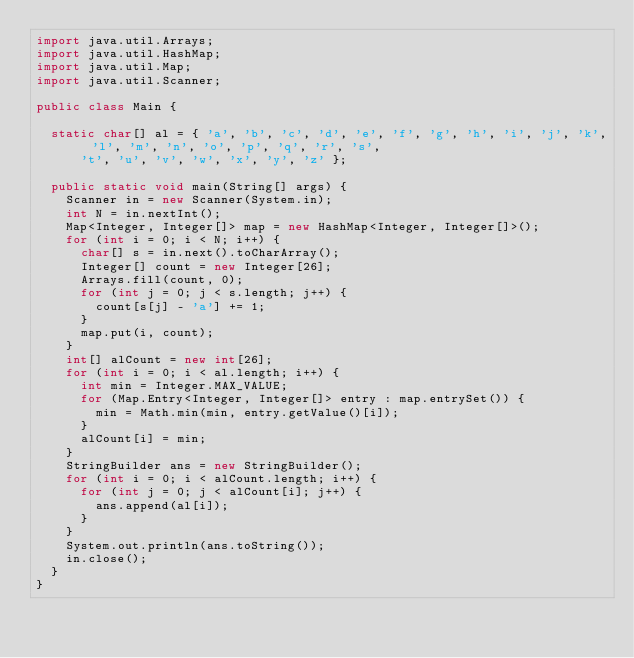<code> <loc_0><loc_0><loc_500><loc_500><_Java_>import java.util.Arrays;
import java.util.HashMap;
import java.util.Map;
import java.util.Scanner;

public class Main {

	static char[] al = { 'a', 'b', 'c', 'd', 'e', 'f', 'g', 'h', 'i', 'j', 'k', 'l', 'm', 'n', 'o', 'p', 'q', 'r', 's',
			't', 'u', 'v', 'w', 'x', 'y', 'z' };

	public static void main(String[] args) {
		Scanner in = new Scanner(System.in);
		int N = in.nextInt();
		Map<Integer, Integer[]> map = new HashMap<Integer, Integer[]>();
		for (int i = 0; i < N; i++) {
			char[] s = in.next().toCharArray();
			Integer[] count = new Integer[26];
			Arrays.fill(count, 0);
			for (int j = 0; j < s.length; j++) {
				count[s[j] - 'a'] += 1;
			}
			map.put(i, count);
		}
		int[] alCount = new int[26];
		for (int i = 0; i < al.length; i++) {
			int min = Integer.MAX_VALUE;
			for (Map.Entry<Integer, Integer[]> entry : map.entrySet()) {
				min = Math.min(min, entry.getValue()[i]);
			}
			alCount[i] = min;
		}
		StringBuilder ans = new StringBuilder();
		for (int i = 0; i < alCount.length; i++) {
			for (int j = 0; j < alCount[i]; j++) {
				ans.append(al[i]);
			}
		}
		System.out.println(ans.toString());
		in.close();
	}
}</code> 